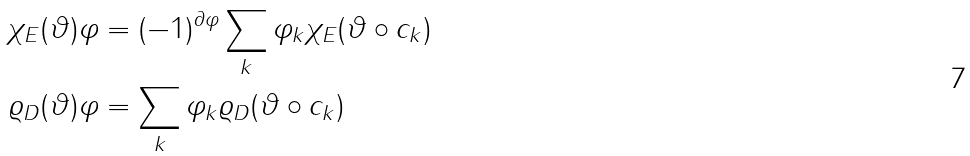Convert formula to latex. <formula><loc_0><loc_0><loc_500><loc_500>\chi _ { E } ( \vartheta ) \varphi & = ( - 1 ) ^ { \partial \varphi } \sum _ { k } \varphi _ { k } \chi _ { E } ( \vartheta \circ c _ { k } ) \\ \varrho _ { D } ( \vartheta ) \varphi & = \sum _ { k } \varphi _ { k } \varrho _ { D } ( \vartheta \circ c _ { k } )</formula> 